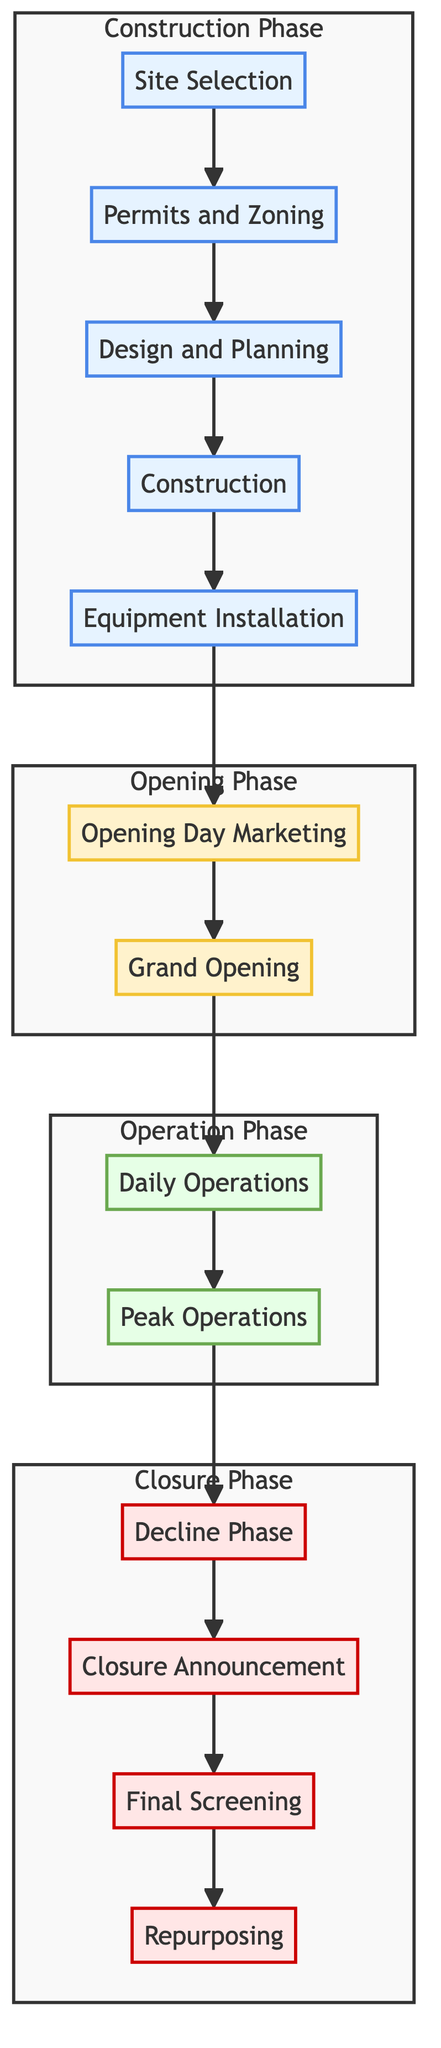What is the first phase of the lifecycle? The first phase in the diagram is labeled "Site Selection," which appears as the initial node in the flowchart.
Answer: Site Selection How many phases are in total in the lifecycle of a drive-in theatre? The diagram has four distinct phases, which are labeled Construction Phase, Opening Phase, Operation Phase, and Closure Phase.
Answer: Four What node follows "Grand Opening"? In the flowchart, the node that follows "Grand Opening" is "Daily Operations." This is determined by following the arrows directing from the "Grand Opening" node.
Answer: Daily Operations What is the last event before repurposing? The last event labeled before "Repurposing" is "Final Screening," which comes right before the final transition to repurposing in the flowchart.
Answer: Final Screening Which phase includes the "Peak Operations" event? The "Peak Operations" event is part of the Operation Phase, as indicated by its placement in that specific subgraph within the diagram.
Answer: Operation Phase How many nodes are there in the Closure Phase? Counting the nodes in the Closure Phase, they are "Decline Phase," "Closure Announcement," "Final Screening," and "Repurposing," totaling four nodes.
Answer: Four What happens after "Decline Phase"? Following the "Decline Phase," the next event is "Closure Announcement," as shown by the direct connection in the flowchart from the Decline Phase to the Closure Announcement node.
Answer: Closure Announcement Which phase is characterized by the marketing activities? The phase characterized by marketing activities includes "Opening Day Marketing" and "Grand Opening," which are both part of the Opening Phase as identified in the flowchart.
Answer: Opening Phase How many construction-related activities are listed? There are five construction-related activities in the Construction Phase, which are "Site Selection," "Permits and Zoning," "Design and Planning," "Construction," and "Equipment Installation."
Answer: Five 